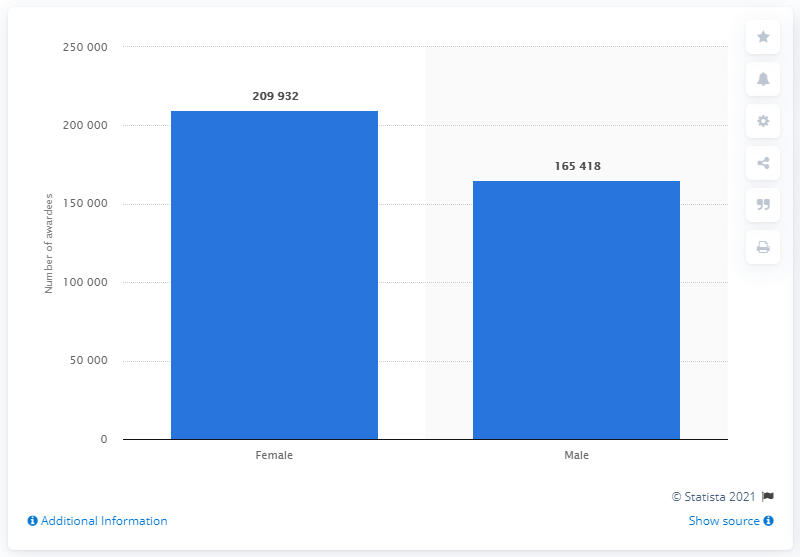How many female students were awarded their undergraduate degree in Karnataka in 2019? In 2019, a total of 209,932 female students successfully obtained their undergraduate degrees in Karnataka, which reflects a strong participation of women in higher education within the state. 